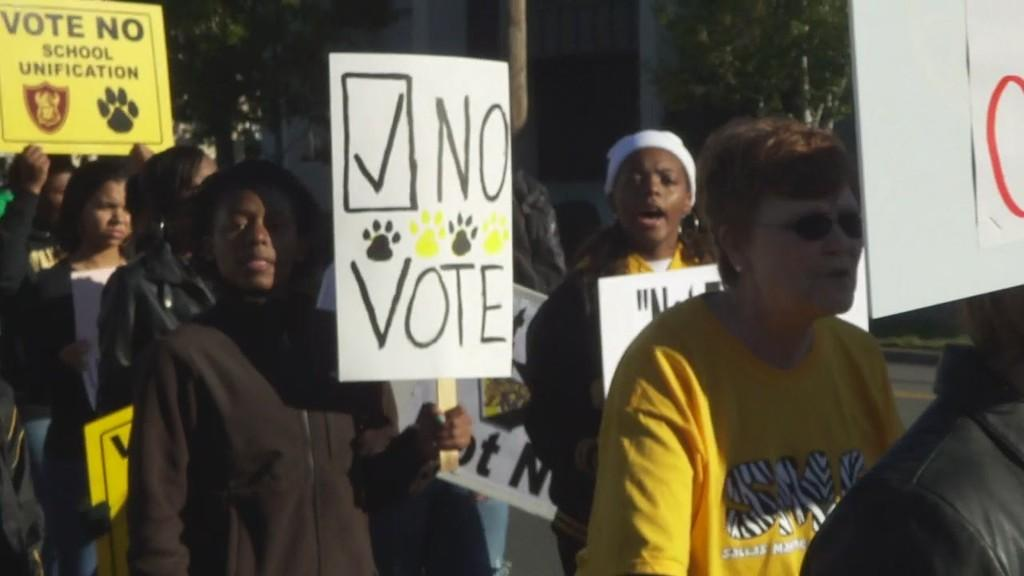What are the people in the image holding? The people in the image are holding boards. What can be seen on the boards? There is text on the boards. What can be seen in the background of the image? There are trees and a pole in the background of the image. What type of treatment is being administered to the bear in the image? There is no bear present in the image, so no treatment can be administered. In which direction is the north pole indicated in the image? The north pole is not indicated in the image, as it is not a compass or map. 